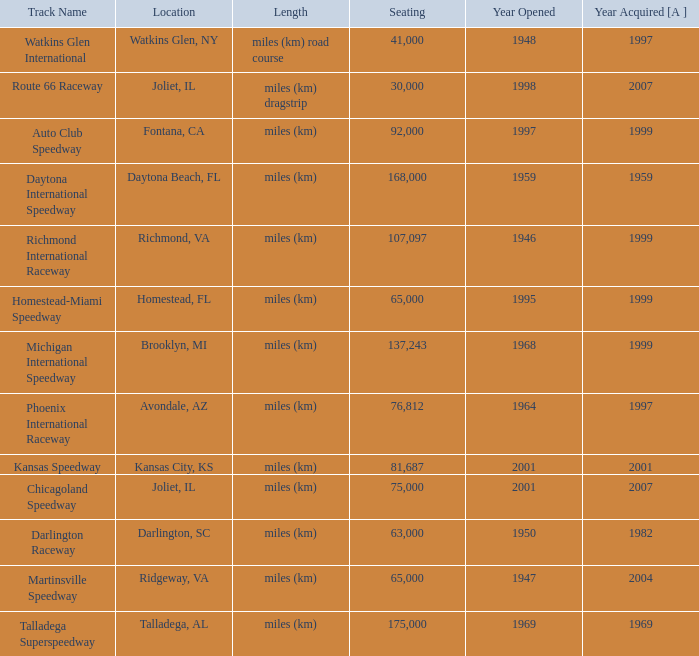What is the year opened for Chicagoland Speedway with a seating smaller than 75,000? None. 